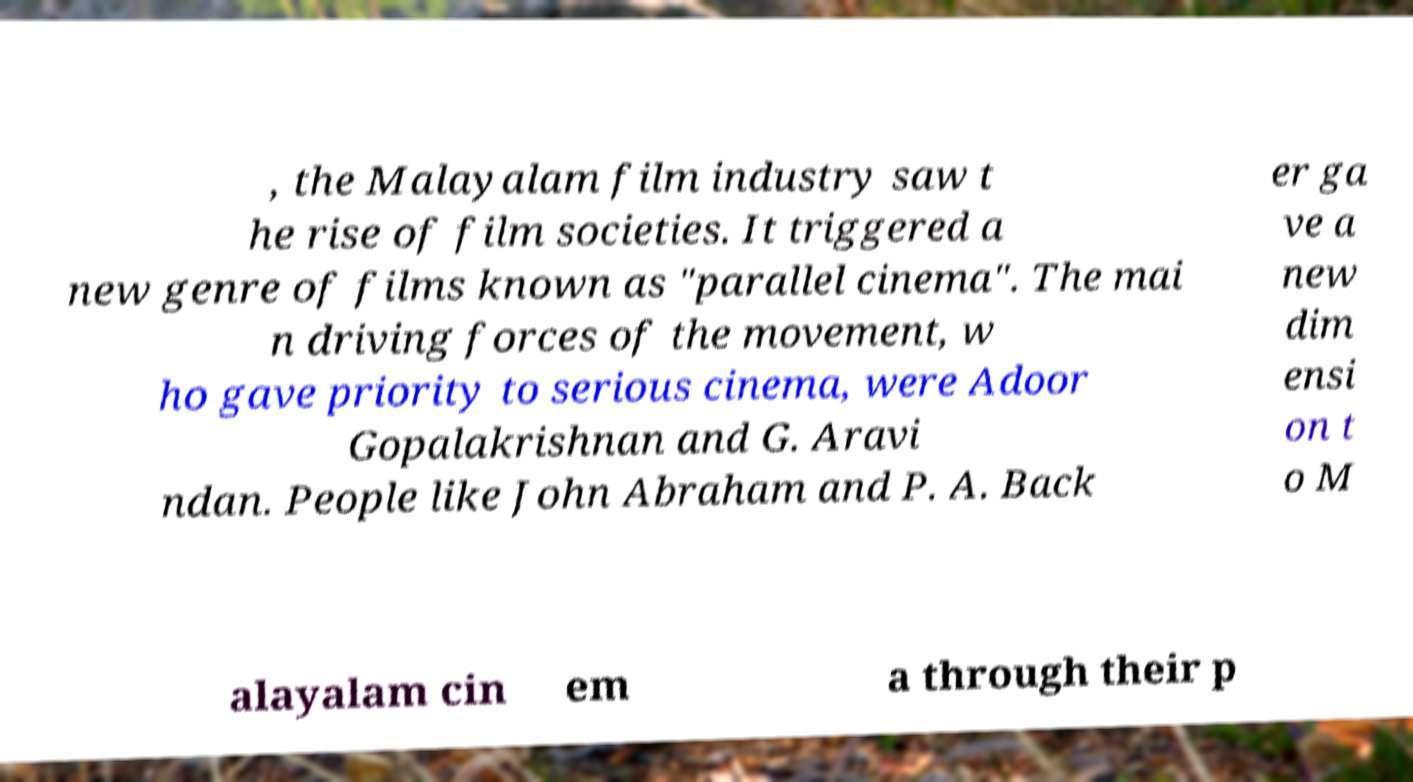I need the written content from this picture converted into text. Can you do that? , the Malayalam film industry saw t he rise of film societies. It triggered a new genre of films known as "parallel cinema". The mai n driving forces of the movement, w ho gave priority to serious cinema, were Adoor Gopalakrishnan and G. Aravi ndan. People like John Abraham and P. A. Back er ga ve a new dim ensi on t o M alayalam cin em a through their p 